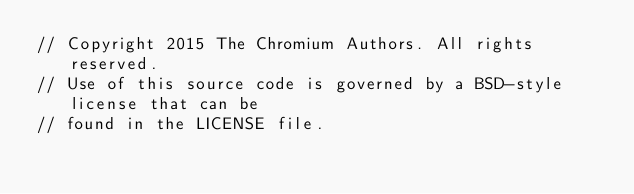Convert code to text. <code><loc_0><loc_0><loc_500><loc_500><_C++_>// Copyright 2015 The Chromium Authors. All rights reserved.
// Use of this source code is governed by a BSD-style license that can be
// found in the LICENSE file.
</code> 